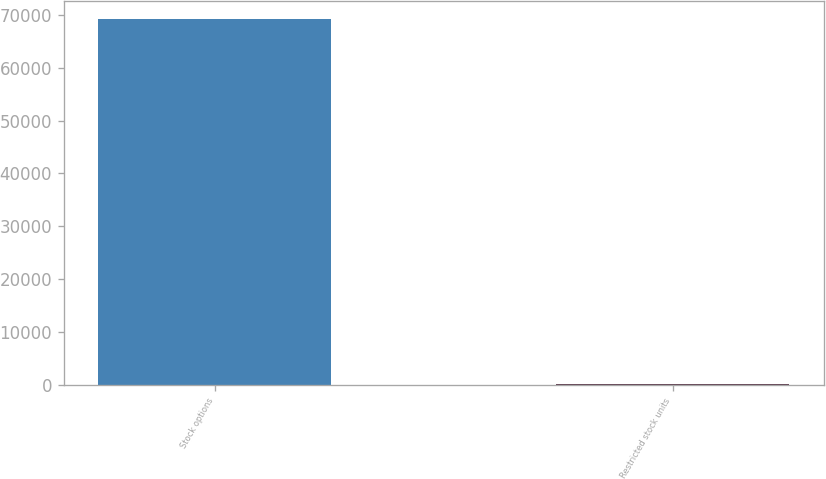Convert chart to OTSL. <chart><loc_0><loc_0><loc_500><loc_500><bar_chart><fcel>Stock options<fcel>Restricted stock units<nl><fcel>69186<fcel>109<nl></chart> 